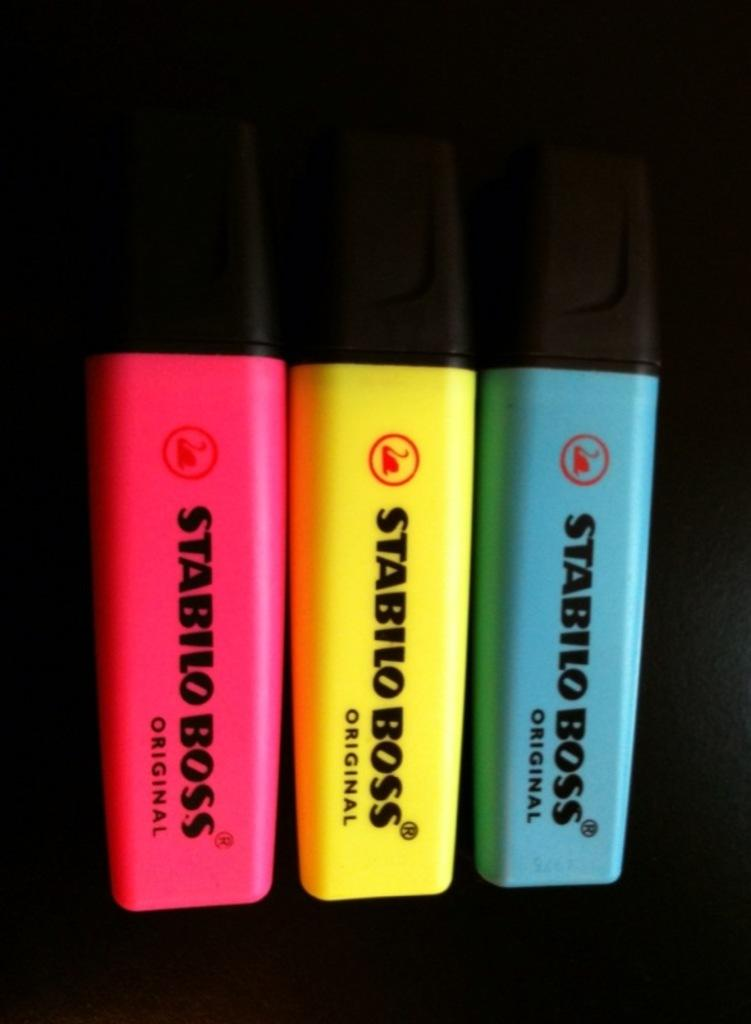What is the main subject of the image? The main subject of the image is three sketches. Can you describe the colors of the sketches? The sketches are in green, yellow, and pink colors. What is the color of the background in the image? The background of the image is dark. Can you see any shoes in the image? No, there are no shoes present in the image. Is there a sea visible in the image? No, there is no sea visible in the image. 